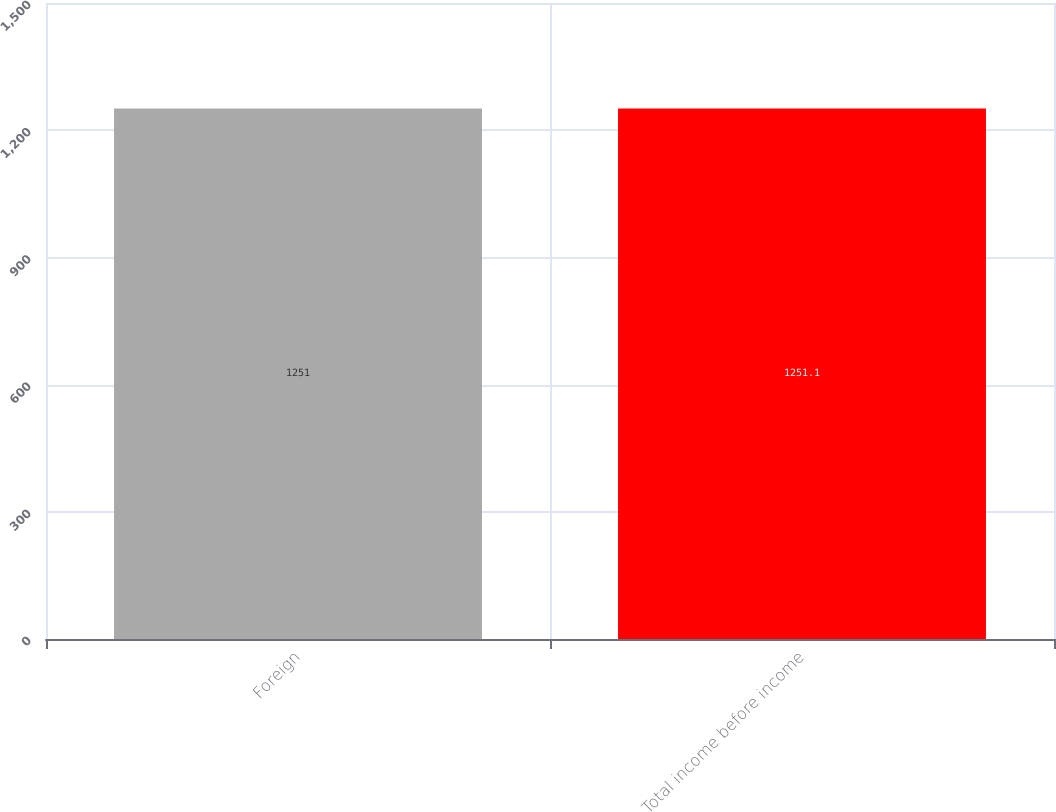Convert chart. <chart><loc_0><loc_0><loc_500><loc_500><bar_chart><fcel>Foreign<fcel>Total income before income<nl><fcel>1251<fcel>1251.1<nl></chart> 